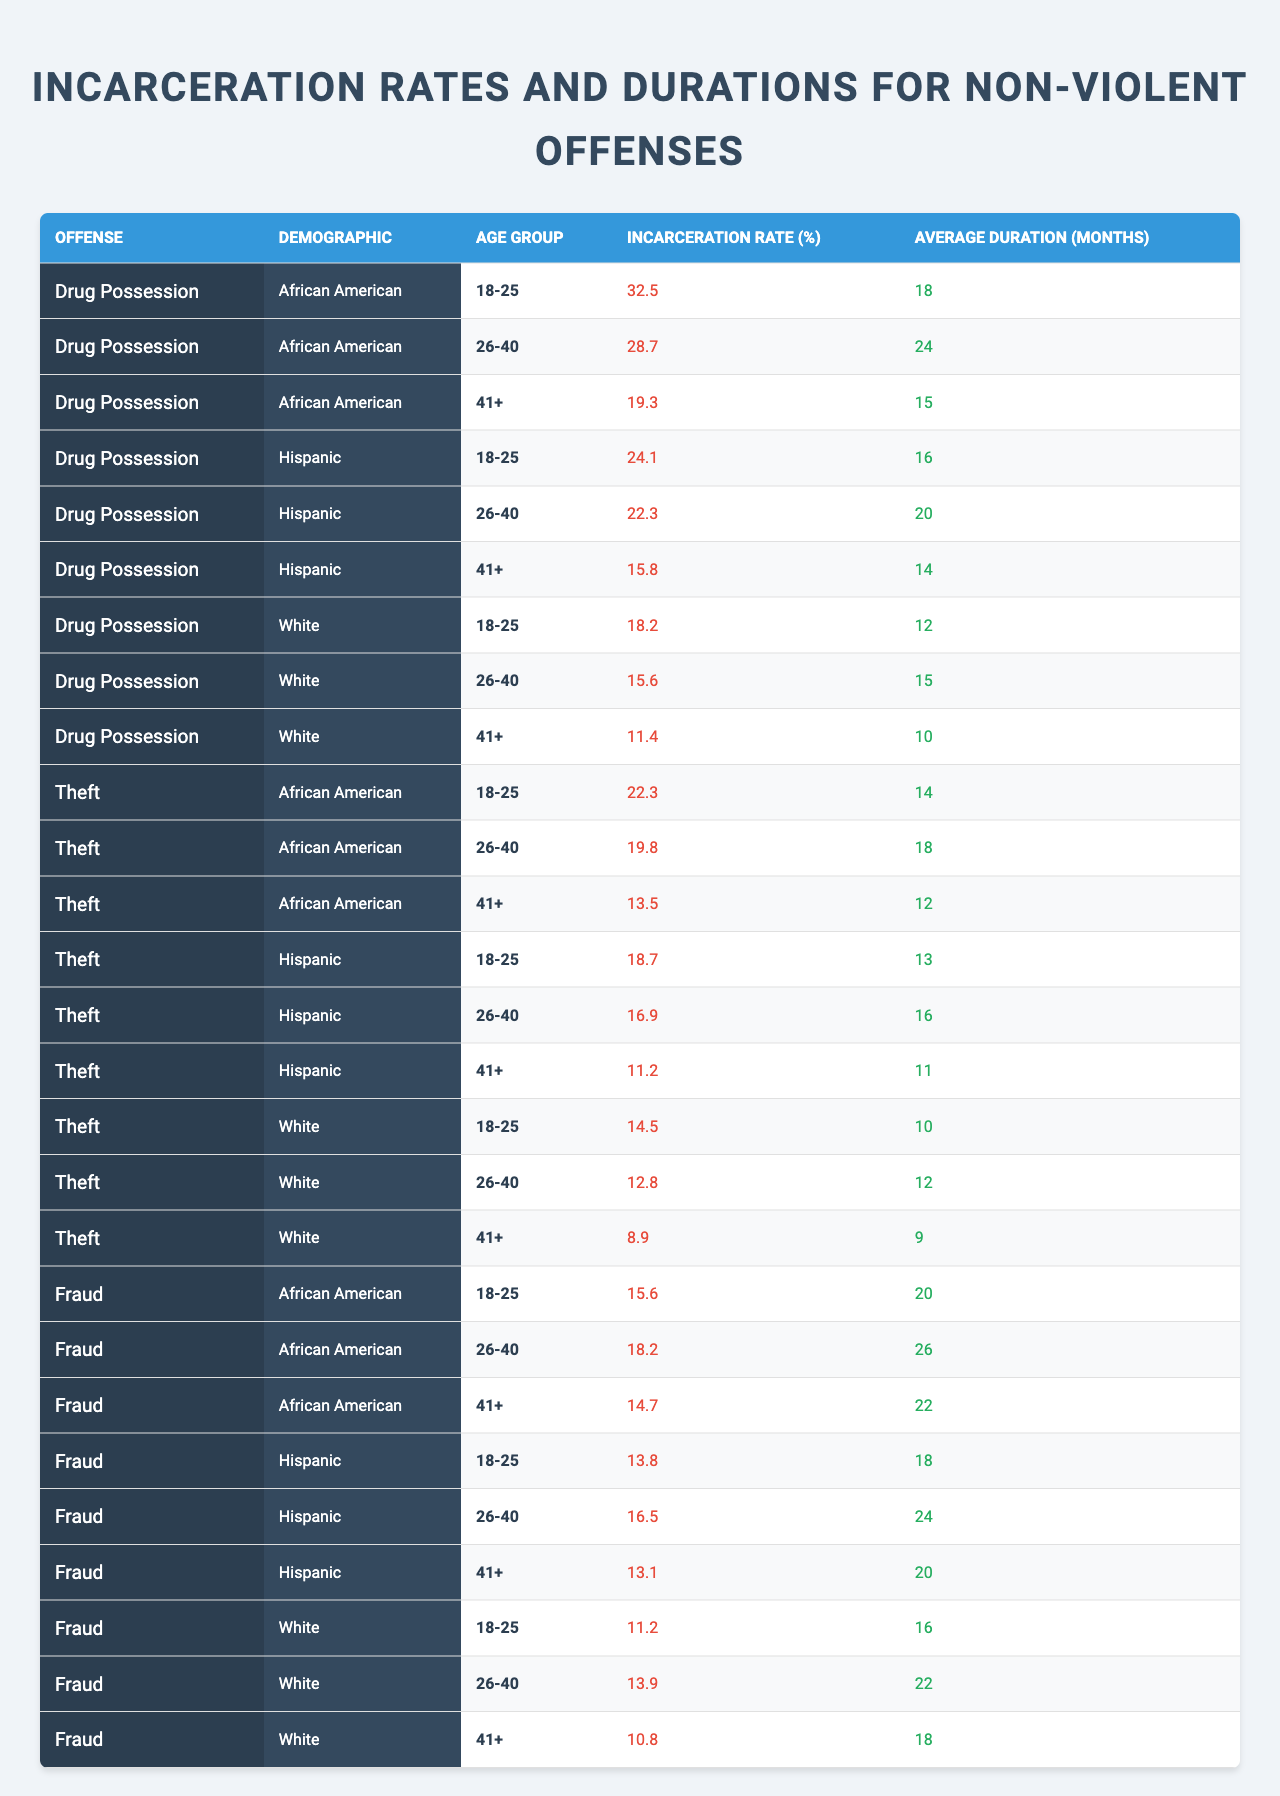What is the incarceration rate for African Americans aged 26-40 for drug possession? The table shows that the incarceration rate for African Americans aged 26-40 for drug possession is 28.7%.
Answer: 28.7% What is the average duration of incarceration for Hispanic individuals aged 41+ for theft? According to the table, the average duration of incarceration for Hispanic individuals aged 41+ for theft is 11 months.
Answer: 11 months Which demographic has the highest incarceration rate for drug possession among 18-25 year-olds? The table indicates that African Americans have the highest incarceration rate for drug possession among 18-25 year-olds at 32.5%.
Answer: African American What is the average incarceration rate for White individuals across the different age groups for fraud? The average incarceration rates for White individuals in fraud are 11.2% (18-25), 13.9% (26-40), and 10.8% (41+). The average is (11.2 + 13.9 + 10.8) / 3 = 11.93%.
Answer: 11.93% Is the average incarceration duration for drug possession higher for African Americans than for Whites aged 41+? For African Americans aged 41+, the average duration is 15 months, while for Whites it's 10 months. Thus, the average duration for African Americans is higher.
Answer: Yes What age group for Hispanic individuals has the lowest incarceration rate for theft? The lowest incarceration rate for Hispanic individuals in theft is for the 41+ age group, which is 11.2%.
Answer: 41+ How does the average duration of incarceration for Hispanic individuals aged 26-40 for drug possession compare to that for African Americans in the same age group? The average duration for Hispanic individuals aged 26-40 for drug possession is 20 months, while for African Americans, it is 24 months. Hence, African Americans have a longer average duration.
Answer: African Americans have a longer duration What is the difference in incarceration rates between White individuals aged 26-40 for fraud and those for theft? The incarceration rate for White individuals aged 26-40 for fraud is 13.9%, while for theft, it is 12.8%. The difference is 1.1%.
Answer: 1.1% Which offense has the highest average duration of incarceration for African American individuals aged 26-40? Looking at the table, the offense of fraud has the highest average duration of 26 months for African Americans aged 26-40.
Answer: Fraud Are Hispanic individuals aged 18-25 more likely to be incarcerated for theft than for drug possession? The incarceration rate for Hispanic individuals aged 18-25 is 18.7% for theft and 24.1% for drug possession, which means they are less likely to be incarcerated for theft.
Answer: No 